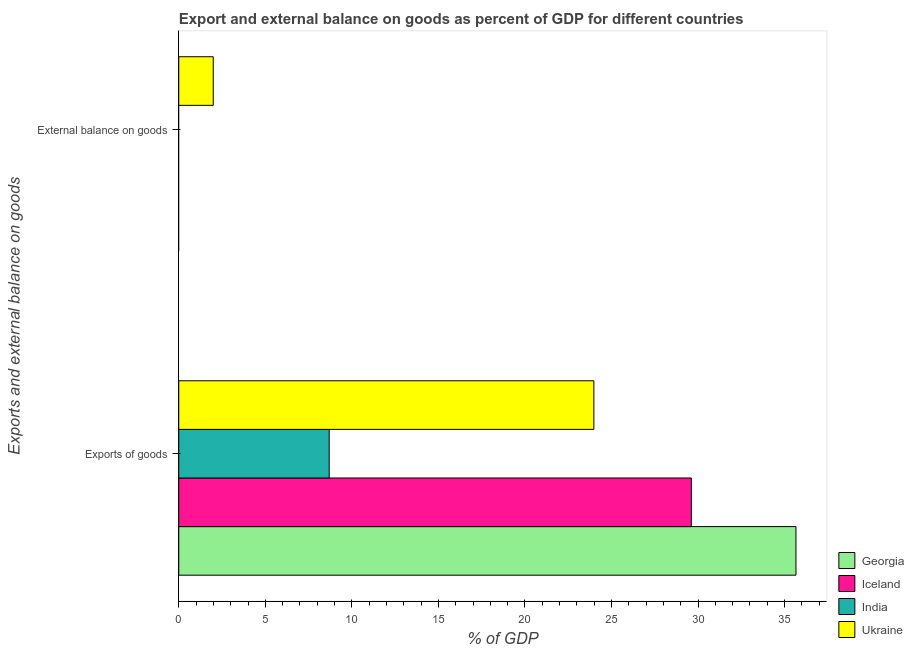How many different coloured bars are there?
Make the answer very short. 4. Are the number of bars per tick equal to the number of legend labels?
Keep it short and to the point. No. How many bars are there on the 1st tick from the top?
Offer a terse response. 1. What is the label of the 1st group of bars from the top?
Provide a short and direct response. External balance on goods. What is the export of goods as percentage of gdp in Ukraine?
Offer a very short reply. 23.98. Across all countries, what is the maximum export of goods as percentage of gdp?
Offer a terse response. 35.66. In which country was the external balance on goods as percentage of gdp maximum?
Keep it short and to the point. Ukraine. What is the total export of goods as percentage of gdp in the graph?
Make the answer very short. 97.94. What is the difference between the export of goods as percentage of gdp in Georgia and that in India?
Give a very brief answer. 26.97. What is the difference between the export of goods as percentage of gdp in Iceland and the external balance on goods as percentage of gdp in Georgia?
Make the answer very short. 29.61. What is the average external balance on goods as percentage of gdp per country?
Ensure brevity in your answer.  0.5. What is the difference between the export of goods as percentage of gdp and external balance on goods as percentage of gdp in Ukraine?
Provide a short and direct response. 21.99. What is the ratio of the export of goods as percentage of gdp in Iceland to that in India?
Offer a very short reply. 3.41. Is the export of goods as percentage of gdp in Ukraine less than that in Georgia?
Ensure brevity in your answer.  Yes. What is the title of the graph?
Give a very brief answer. Export and external balance on goods as percent of GDP for different countries. What is the label or title of the X-axis?
Your response must be concise. % of GDP. What is the label or title of the Y-axis?
Offer a terse response. Exports and external balance on goods. What is the % of GDP of Georgia in Exports of goods?
Provide a succinct answer. 35.66. What is the % of GDP of Iceland in Exports of goods?
Provide a succinct answer. 29.61. What is the % of GDP in India in Exports of goods?
Offer a very short reply. 8.69. What is the % of GDP in Ukraine in Exports of goods?
Make the answer very short. 23.98. What is the % of GDP of Georgia in External balance on goods?
Your answer should be compact. 0. What is the % of GDP in Iceland in External balance on goods?
Offer a very short reply. 0. What is the % of GDP in Ukraine in External balance on goods?
Offer a very short reply. 1.99. Across all Exports and external balance on goods, what is the maximum % of GDP of Georgia?
Keep it short and to the point. 35.66. Across all Exports and external balance on goods, what is the maximum % of GDP of Iceland?
Your response must be concise. 29.61. Across all Exports and external balance on goods, what is the maximum % of GDP of India?
Give a very brief answer. 8.69. Across all Exports and external balance on goods, what is the maximum % of GDP in Ukraine?
Offer a very short reply. 23.98. Across all Exports and external balance on goods, what is the minimum % of GDP in Iceland?
Provide a succinct answer. 0. Across all Exports and external balance on goods, what is the minimum % of GDP of Ukraine?
Your answer should be very brief. 1.99. What is the total % of GDP in Georgia in the graph?
Offer a terse response. 35.66. What is the total % of GDP in Iceland in the graph?
Ensure brevity in your answer.  29.61. What is the total % of GDP of India in the graph?
Provide a succinct answer. 8.69. What is the total % of GDP in Ukraine in the graph?
Keep it short and to the point. 25.97. What is the difference between the % of GDP in Ukraine in Exports of goods and that in External balance on goods?
Ensure brevity in your answer.  21.99. What is the difference between the % of GDP of Georgia in Exports of goods and the % of GDP of Ukraine in External balance on goods?
Ensure brevity in your answer.  33.67. What is the difference between the % of GDP of Iceland in Exports of goods and the % of GDP of Ukraine in External balance on goods?
Your answer should be very brief. 27.62. What is the difference between the % of GDP in India in Exports of goods and the % of GDP in Ukraine in External balance on goods?
Offer a terse response. 6.7. What is the average % of GDP of Georgia per Exports and external balance on goods?
Your answer should be compact. 17.83. What is the average % of GDP of Iceland per Exports and external balance on goods?
Offer a very short reply. 14.81. What is the average % of GDP of India per Exports and external balance on goods?
Ensure brevity in your answer.  4.35. What is the average % of GDP in Ukraine per Exports and external balance on goods?
Ensure brevity in your answer.  12.99. What is the difference between the % of GDP of Georgia and % of GDP of Iceland in Exports of goods?
Ensure brevity in your answer.  6.05. What is the difference between the % of GDP in Georgia and % of GDP in India in Exports of goods?
Keep it short and to the point. 26.97. What is the difference between the % of GDP of Georgia and % of GDP of Ukraine in Exports of goods?
Make the answer very short. 11.68. What is the difference between the % of GDP in Iceland and % of GDP in India in Exports of goods?
Offer a very short reply. 20.92. What is the difference between the % of GDP in Iceland and % of GDP in Ukraine in Exports of goods?
Offer a very short reply. 5.63. What is the difference between the % of GDP of India and % of GDP of Ukraine in Exports of goods?
Your response must be concise. -15.29. What is the ratio of the % of GDP of Ukraine in Exports of goods to that in External balance on goods?
Make the answer very short. 12.04. What is the difference between the highest and the second highest % of GDP in Ukraine?
Offer a very short reply. 21.99. What is the difference between the highest and the lowest % of GDP in Georgia?
Offer a terse response. 35.66. What is the difference between the highest and the lowest % of GDP of Iceland?
Ensure brevity in your answer.  29.61. What is the difference between the highest and the lowest % of GDP of India?
Give a very brief answer. 8.69. What is the difference between the highest and the lowest % of GDP of Ukraine?
Offer a very short reply. 21.99. 